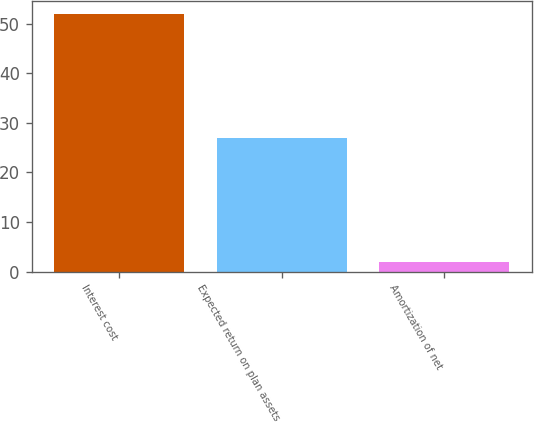<chart> <loc_0><loc_0><loc_500><loc_500><bar_chart><fcel>Interest cost<fcel>Expected return on plan assets<fcel>Amortization of net<nl><fcel>52<fcel>27<fcel>2<nl></chart> 